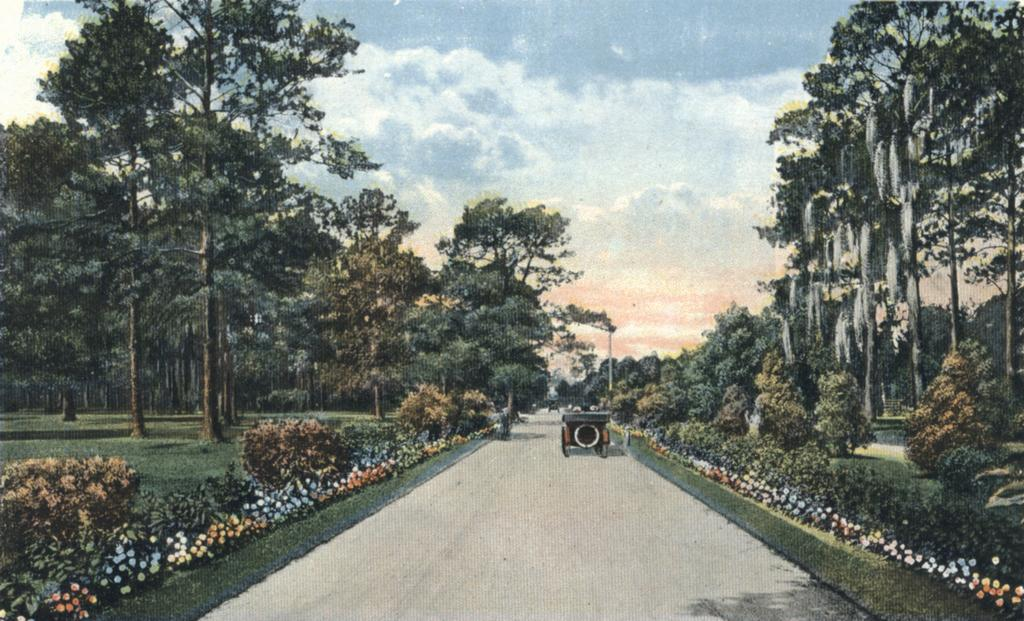What can be seen at the top of the image? The sky with clouds is visible at the top of the image. What is located on either side of the road in the image? There are trees on either side of the road. What type of vegetation is present in the image? There are plants and flowers in the image. What is moving along the road in the image? There is a vehicle on the road in the image. What type of appliance can be seen hanging from the tree on the left side of the image? There is no appliance present in the image; it features trees, plants, flowers, and a vehicle on the road. Can you tell me how many icicles are hanging from the vehicle in the image? There are no icicles present in the image; it is not snowing or cold enough for icicles to form. 